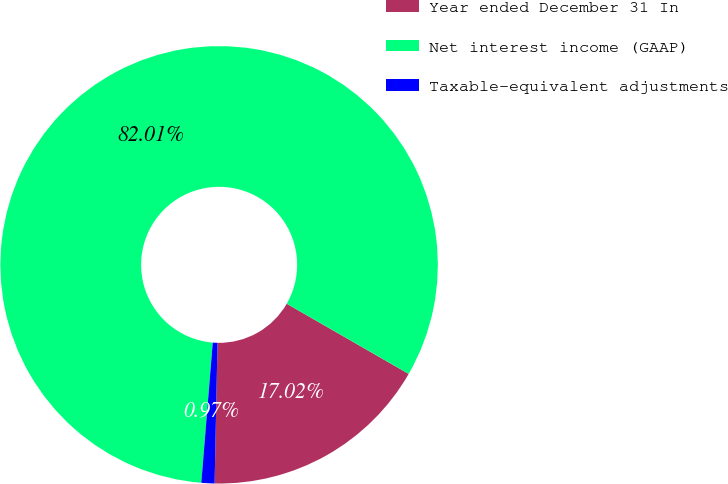<chart> <loc_0><loc_0><loc_500><loc_500><pie_chart><fcel>Year ended December 31 In<fcel>Net interest income (GAAP)<fcel>Taxable-equivalent adjustments<nl><fcel>17.02%<fcel>82.01%<fcel>0.97%<nl></chart> 